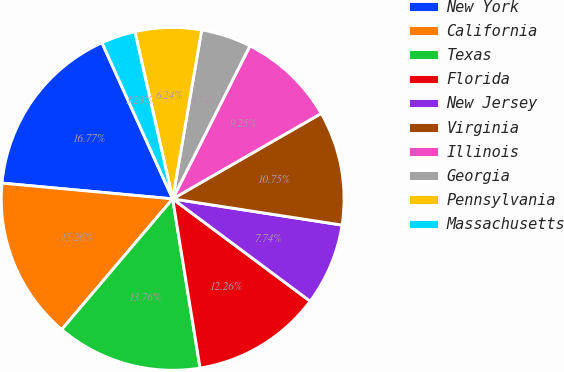<chart> <loc_0><loc_0><loc_500><loc_500><pie_chart><fcel>New York<fcel>California<fcel>Texas<fcel>Florida<fcel>New Jersey<fcel>Virginia<fcel>Illinois<fcel>Georgia<fcel>Pennsylvania<fcel>Massachusetts<nl><fcel>16.77%<fcel>15.26%<fcel>13.76%<fcel>12.26%<fcel>7.74%<fcel>10.75%<fcel>9.25%<fcel>4.74%<fcel>6.24%<fcel>3.23%<nl></chart> 